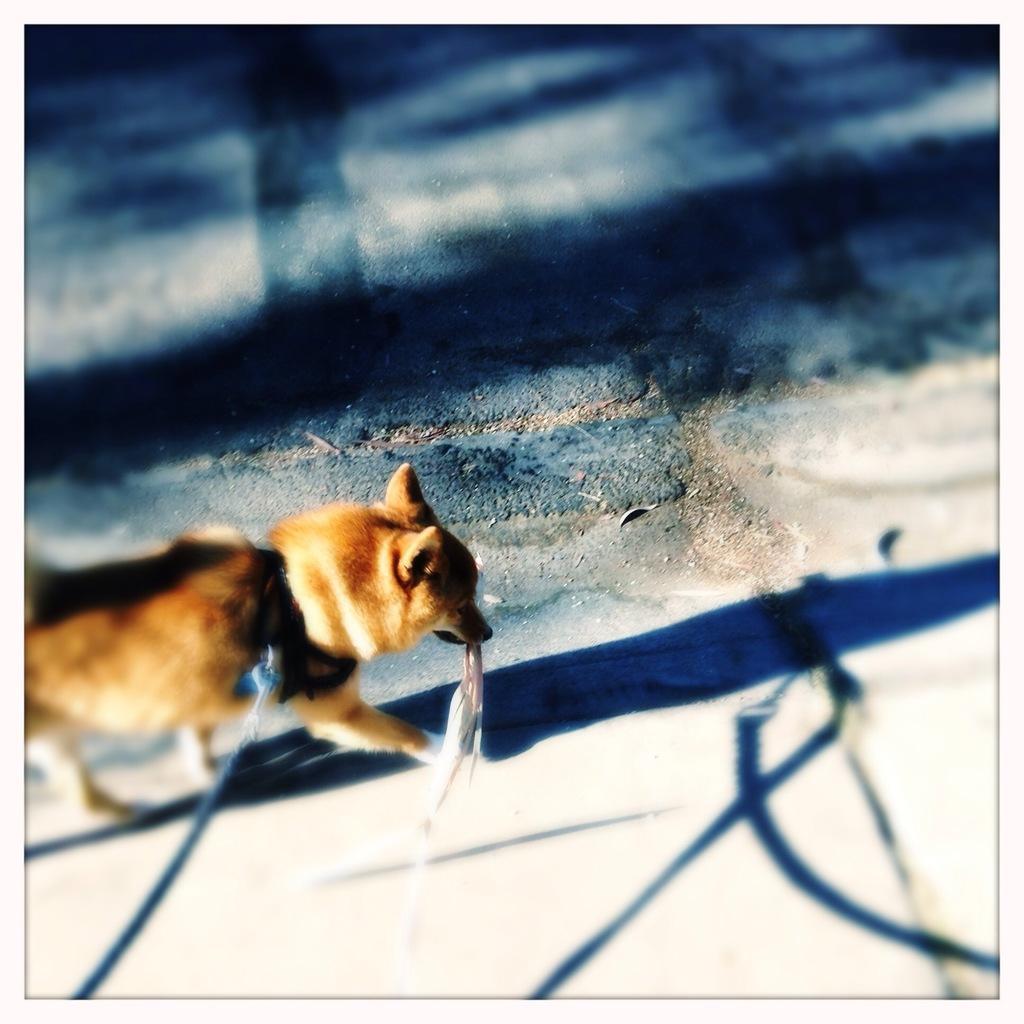In one or two sentences, can you explain what this image depicts? In this image there is a dog on the road and holding a cloth, there is a chain to the dog and some reflections on the ground. 